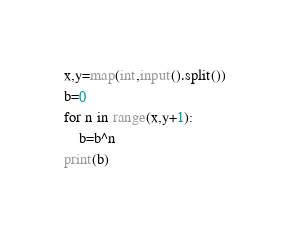<code> <loc_0><loc_0><loc_500><loc_500><_Python_>x,y=map(int,input().split())
b=0
for n in range(x,y+1):
    b=b^n
print(b)</code> 